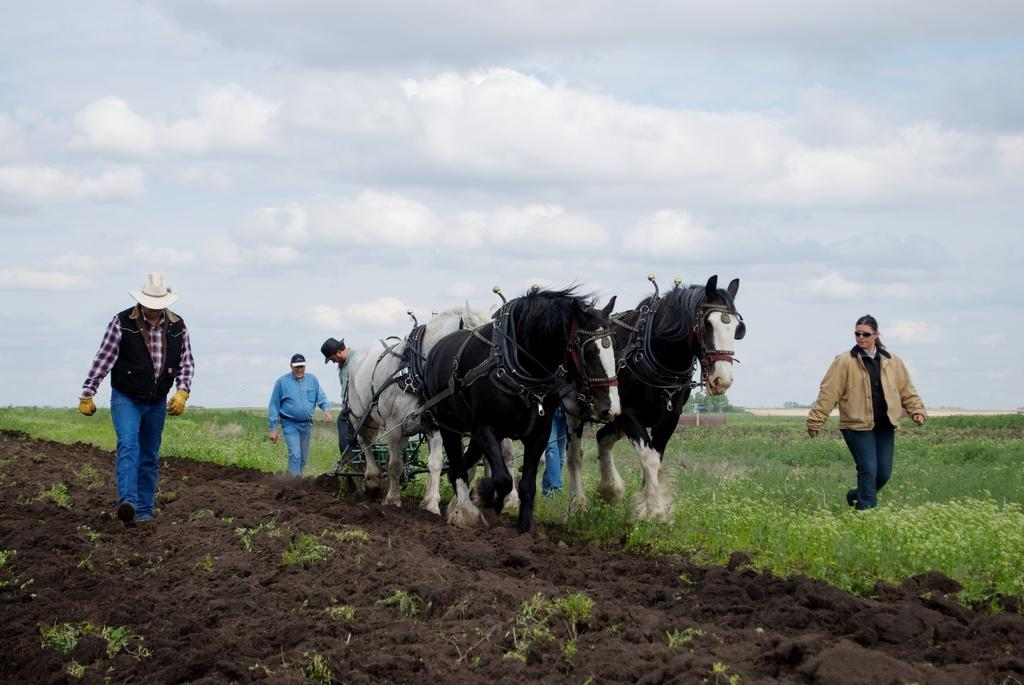What is the main subject of the image? The main subject of the image is a man. What is the man doing in the image? The man is ploughing a land. How is the man ploughing the land? The man is using four horses for ploughing. Are there any other people in the image? Yes, there are people around the man watching the process. What type of haircut does the man have while ploughing the land? The image does not provide information about the man's haircut. How many birds can be seen flying in the image? There are no birds visible in the image. 